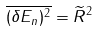Convert formula to latex. <formula><loc_0><loc_0><loc_500><loc_500>\overline { ( \delta E _ { n } ) ^ { 2 } } = \widetilde { R } ^ { 2 }</formula> 